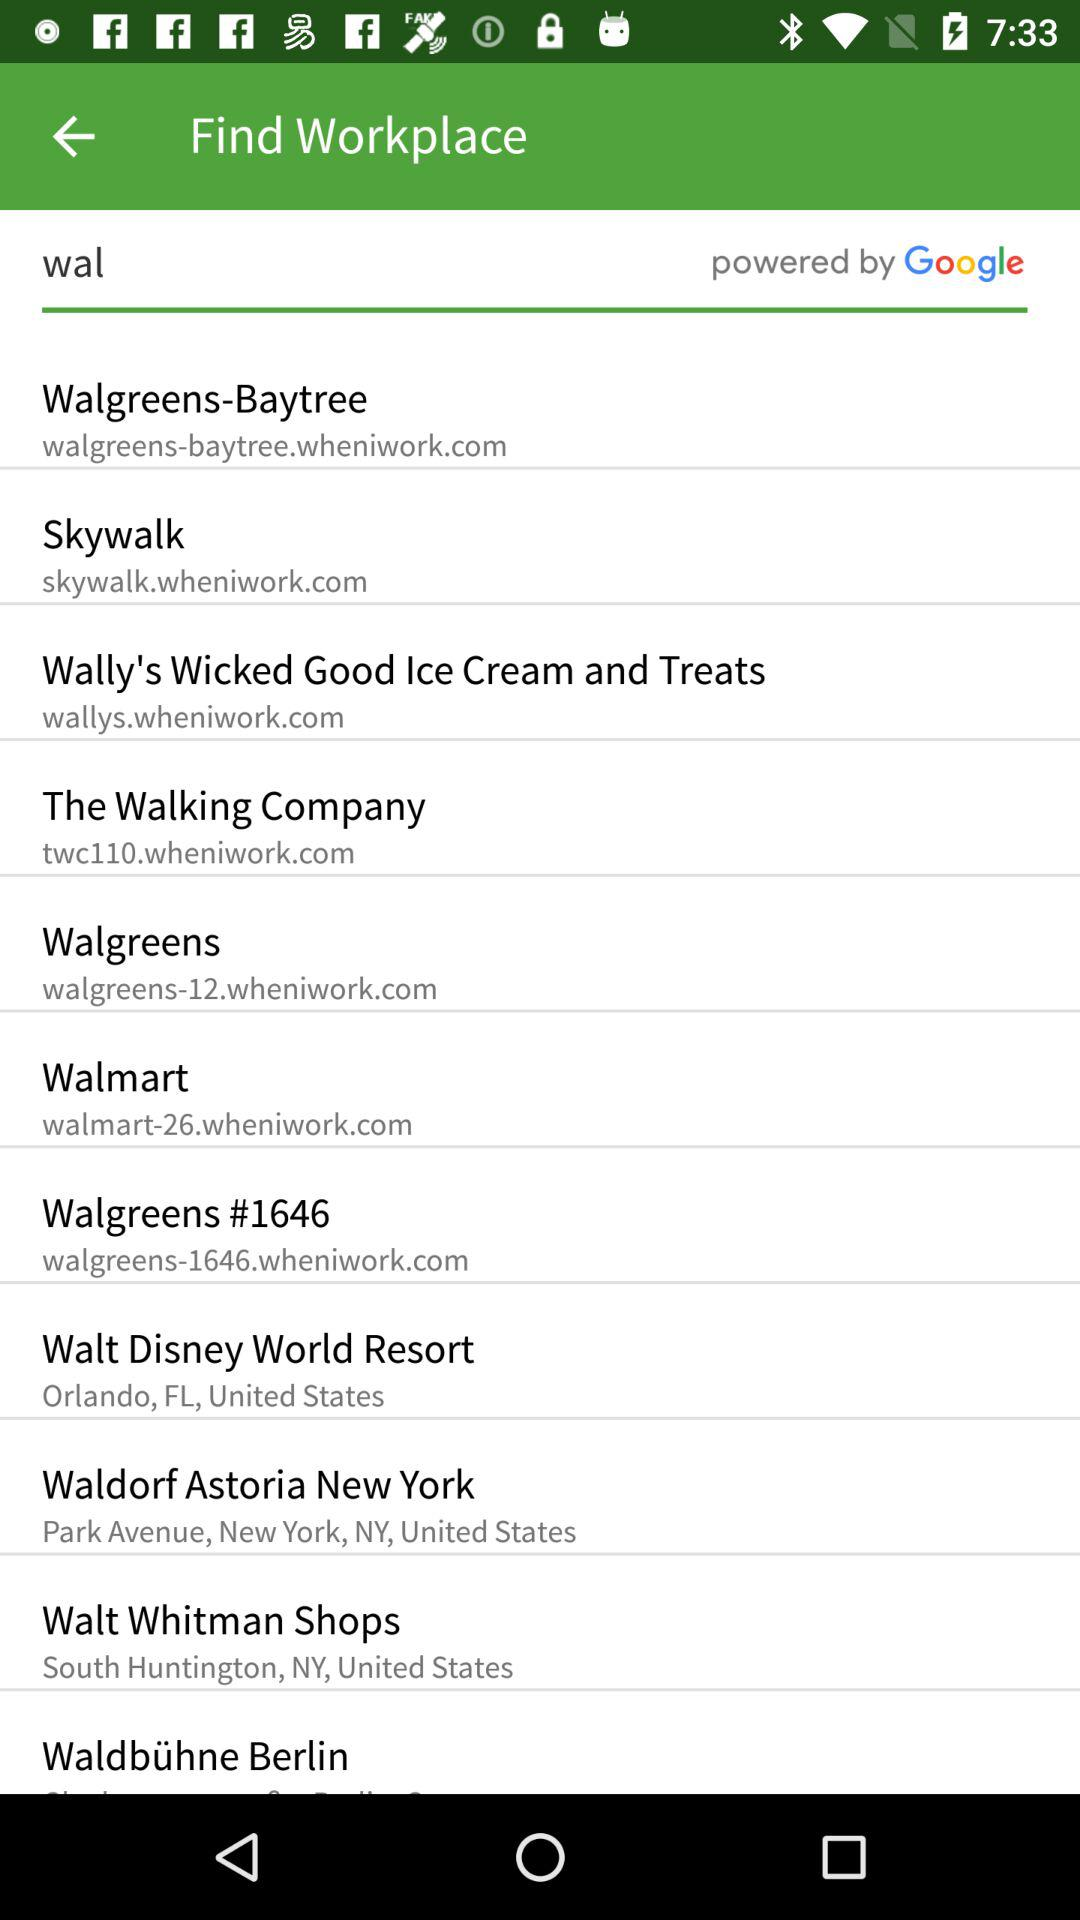What is Walmart's URL address? The URL address is walmart-26.wheniwork.com. 